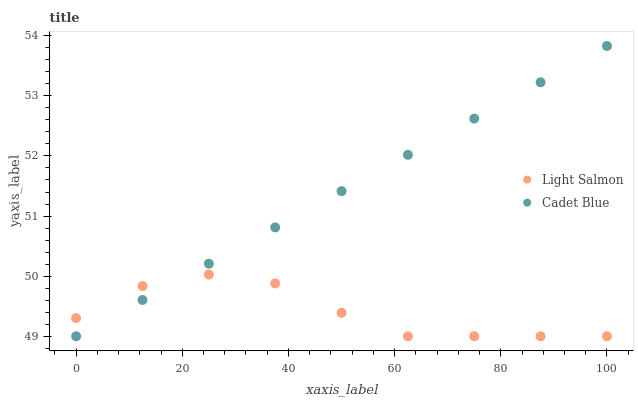Does Light Salmon have the minimum area under the curve?
Answer yes or no. Yes. Does Cadet Blue have the maximum area under the curve?
Answer yes or no. Yes. Does Cadet Blue have the minimum area under the curve?
Answer yes or no. No. Is Cadet Blue the smoothest?
Answer yes or no. Yes. Is Light Salmon the roughest?
Answer yes or no. Yes. Is Cadet Blue the roughest?
Answer yes or no. No. Does Light Salmon have the lowest value?
Answer yes or no. Yes. Does Cadet Blue have the highest value?
Answer yes or no. Yes. Does Cadet Blue intersect Light Salmon?
Answer yes or no. Yes. Is Cadet Blue less than Light Salmon?
Answer yes or no. No. Is Cadet Blue greater than Light Salmon?
Answer yes or no. No. 